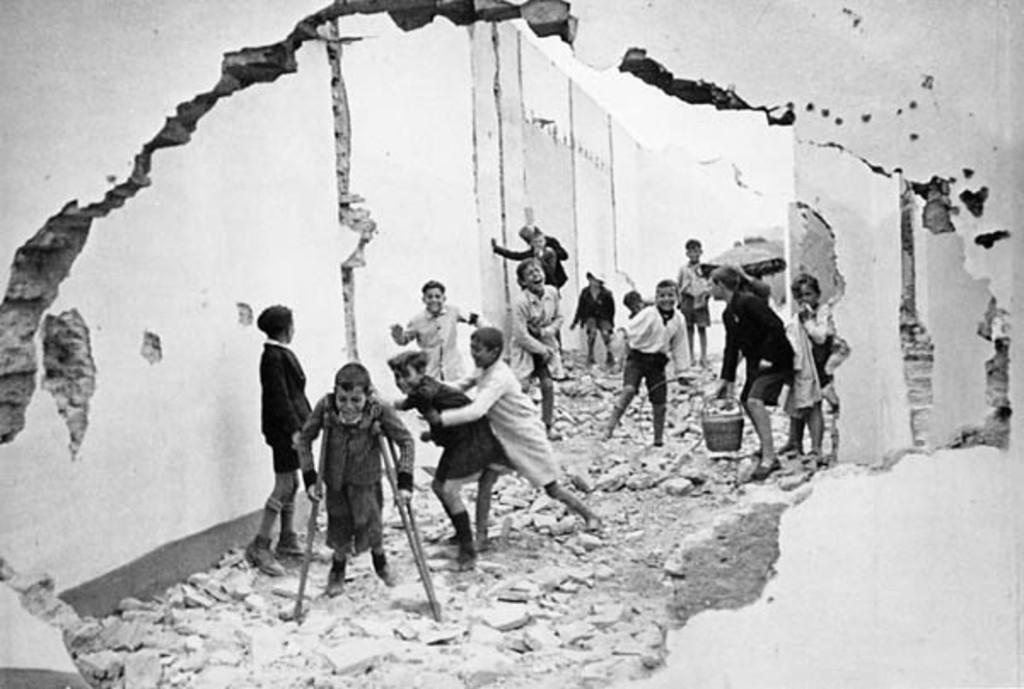What can be seen in the image? There are children standing in the image. What is the color scheme of the image? The image is black and white in color. What suggestion is being made by the hand in the image? There is no hand present in the image, and therefore no suggestion can be made. 